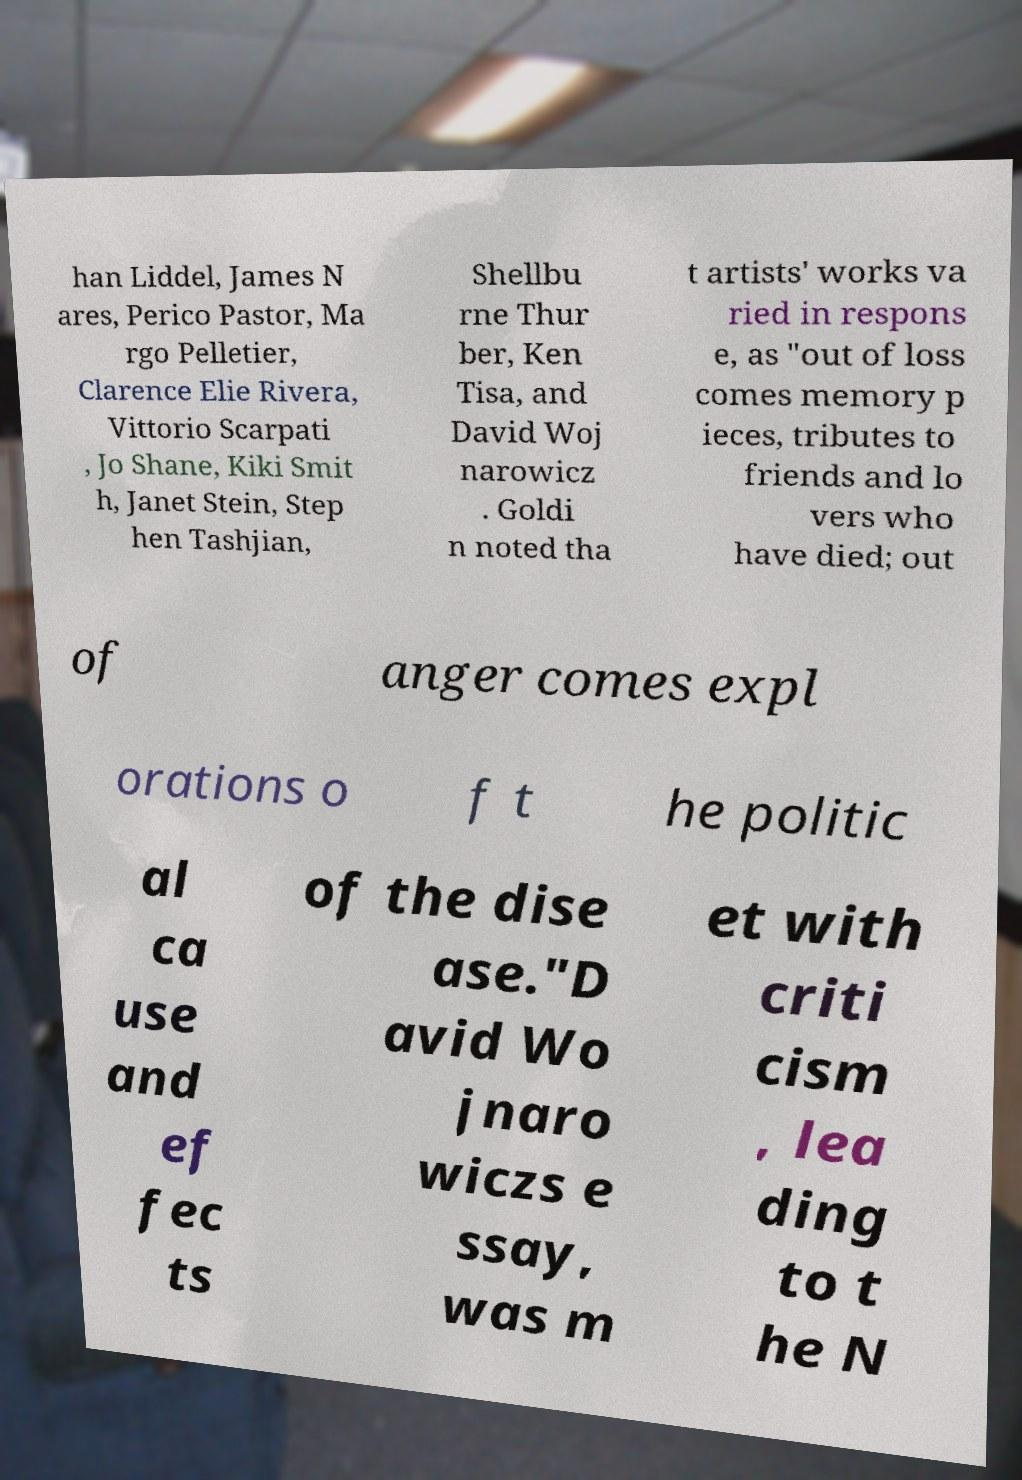Please identify and transcribe the text found in this image. han Liddel, James N ares, Perico Pastor, Ma rgo Pelletier, Clarence Elie Rivera, Vittorio Scarpati , Jo Shane, Kiki Smit h, Janet Stein, Step hen Tashjian, Shellbu rne Thur ber, Ken Tisa, and David Woj narowicz . Goldi n noted tha t artists' works va ried in respons e, as "out of loss comes memory p ieces, tributes to friends and lo vers who have died; out of anger comes expl orations o f t he politic al ca use and ef fec ts of the dise ase."D avid Wo jnaro wiczs e ssay, was m et with criti cism , lea ding to t he N 